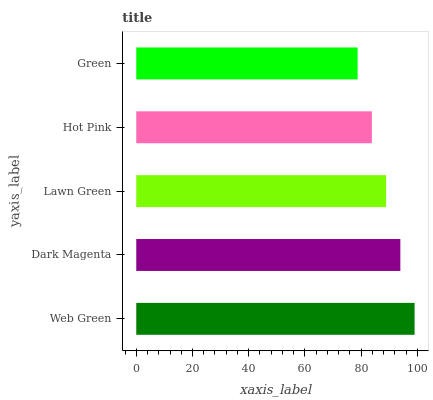Is Green the minimum?
Answer yes or no. Yes. Is Web Green the maximum?
Answer yes or no. Yes. Is Dark Magenta the minimum?
Answer yes or no. No. Is Dark Magenta the maximum?
Answer yes or no. No. Is Web Green greater than Dark Magenta?
Answer yes or no. Yes. Is Dark Magenta less than Web Green?
Answer yes or no. Yes. Is Dark Magenta greater than Web Green?
Answer yes or no. No. Is Web Green less than Dark Magenta?
Answer yes or no. No. Is Lawn Green the high median?
Answer yes or no. Yes. Is Lawn Green the low median?
Answer yes or no. Yes. Is Dark Magenta the high median?
Answer yes or no. No. Is Green the low median?
Answer yes or no. No. 